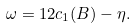Convert formula to latex. <formula><loc_0><loc_0><loc_500><loc_500>\omega = 1 2 c _ { 1 } ( B ) - \eta .</formula> 